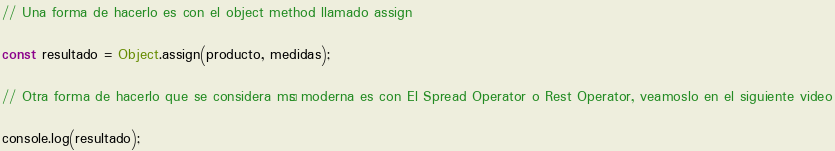Convert code to text. <code><loc_0><loc_0><loc_500><loc_500><_JavaScript_>// Una forma de hacerlo es con el object method llamado assign

const resultado = Object.assign(producto, medidas);

// Otra forma de hacerlo que se considera más moderna es con El Spread Operator o Rest Operator, veamoslo en el siguiente video

console.log(resultado);
</code> 